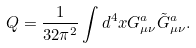Convert formula to latex. <formula><loc_0><loc_0><loc_500><loc_500>Q = \frac { 1 } { 3 2 \pi ^ { 2 } } \int d ^ { 4 } x G ^ { a } _ { \mu \nu } \tilde { G } ^ { a } _ { \mu \nu } .</formula> 